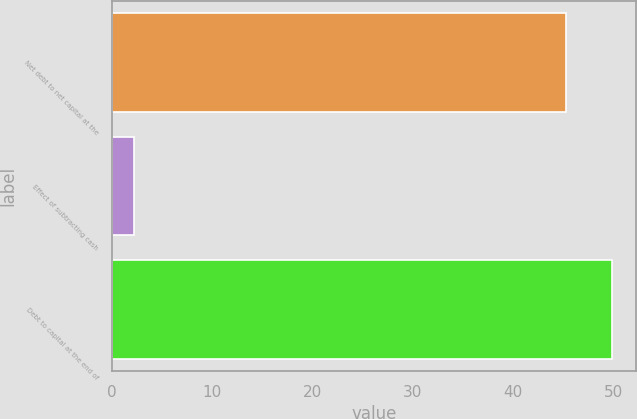Convert chart to OTSL. <chart><loc_0><loc_0><loc_500><loc_500><bar_chart><fcel>Net debt to net capital at the<fcel>Effect of subtracting cash<fcel>Debt to capital at the end of<nl><fcel>45.3<fcel>2.2<fcel>49.83<nl></chart> 